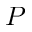<formula> <loc_0><loc_0><loc_500><loc_500>P</formula> 